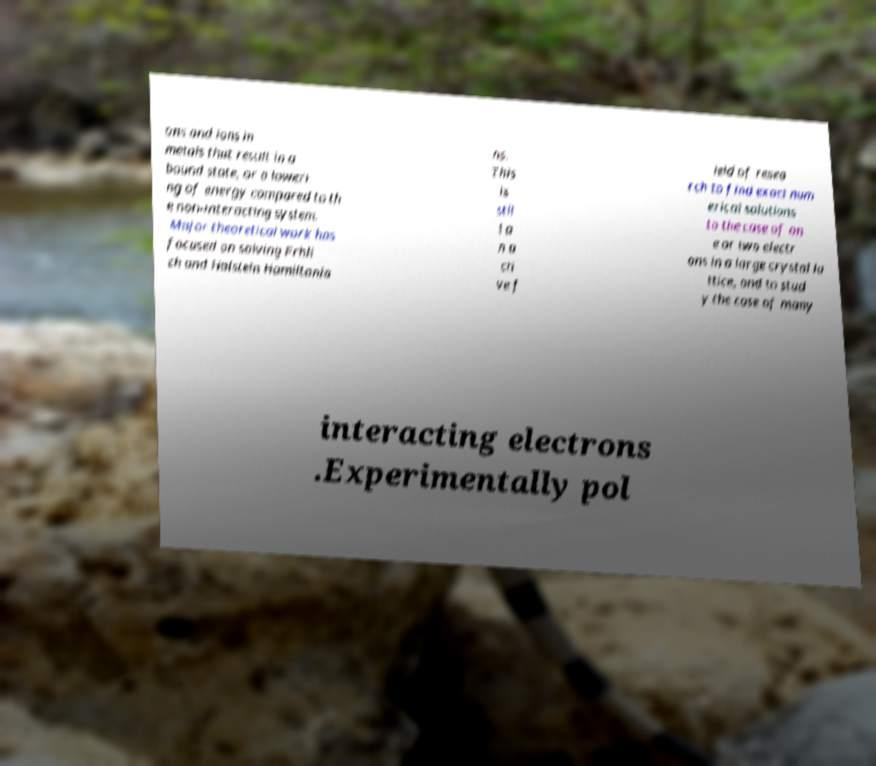What messages or text are displayed in this image? I need them in a readable, typed format. ons and ions in metals that result in a bound state, or a loweri ng of energy compared to th e non-interacting system. Major theoretical work has focused on solving Frhli ch and Holstein Hamiltonia ns. This is stil l a n a cti ve f ield of resea rch to find exact num erical solutions to the case of on e or two electr ons in a large crystal la ttice, and to stud y the case of many interacting electrons .Experimentally pol 